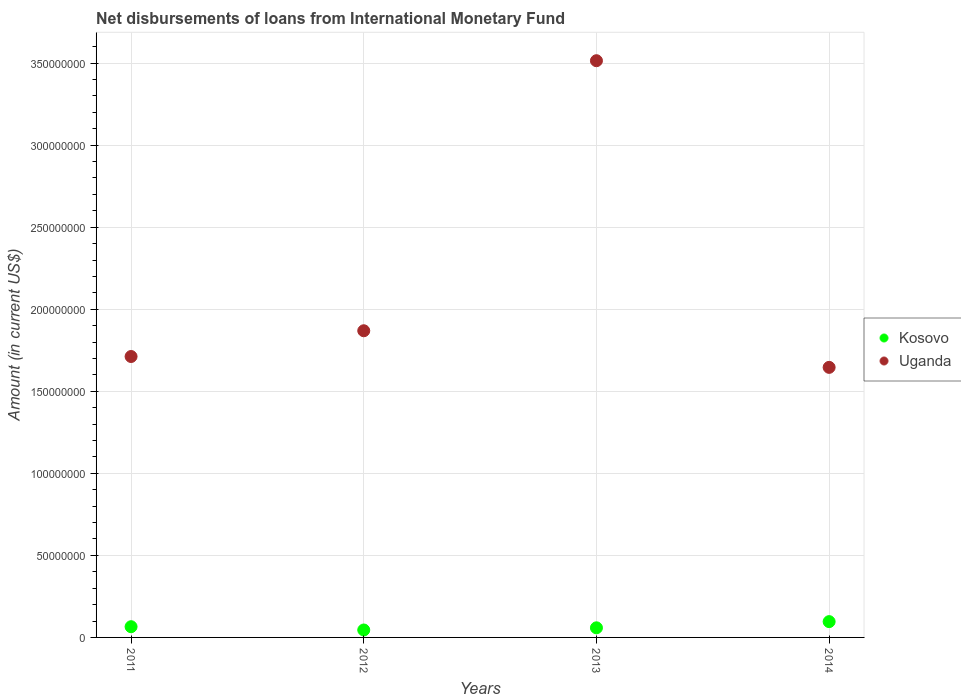Is the number of dotlines equal to the number of legend labels?
Provide a succinct answer. Yes. What is the amount of loans disbursed in Uganda in 2014?
Give a very brief answer. 1.65e+08. Across all years, what is the maximum amount of loans disbursed in Kosovo?
Offer a terse response. 9.63e+06. Across all years, what is the minimum amount of loans disbursed in Uganda?
Provide a succinct answer. 1.65e+08. In which year was the amount of loans disbursed in Uganda maximum?
Ensure brevity in your answer.  2013. In which year was the amount of loans disbursed in Uganda minimum?
Your response must be concise. 2014. What is the total amount of loans disbursed in Kosovo in the graph?
Provide a succinct answer. 2.66e+07. What is the difference between the amount of loans disbursed in Kosovo in 2011 and that in 2012?
Provide a succinct answer. 2.00e+06. What is the difference between the amount of loans disbursed in Kosovo in 2011 and the amount of loans disbursed in Uganda in 2014?
Your answer should be very brief. -1.58e+08. What is the average amount of loans disbursed in Uganda per year?
Ensure brevity in your answer.  2.19e+08. In the year 2011, what is the difference between the amount of loans disbursed in Uganda and amount of loans disbursed in Kosovo?
Ensure brevity in your answer.  1.65e+08. What is the ratio of the amount of loans disbursed in Kosovo in 2012 to that in 2013?
Provide a short and direct response. 0.77. What is the difference between the highest and the second highest amount of loans disbursed in Uganda?
Ensure brevity in your answer.  1.65e+08. What is the difference between the highest and the lowest amount of loans disbursed in Uganda?
Provide a short and direct response. 1.87e+08. Is the sum of the amount of loans disbursed in Uganda in 2012 and 2013 greater than the maximum amount of loans disbursed in Kosovo across all years?
Your response must be concise. Yes. Does the amount of loans disbursed in Kosovo monotonically increase over the years?
Provide a succinct answer. No. Is the amount of loans disbursed in Uganda strictly greater than the amount of loans disbursed in Kosovo over the years?
Your answer should be very brief. Yes. How many dotlines are there?
Keep it short and to the point. 2. Are the values on the major ticks of Y-axis written in scientific E-notation?
Your response must be concise. No. Does the graph contain any zero values?
Make the answer very short. No. Does the graph contain grids?
Make the answer very short. Yes. How many legend labels are there?
Offer a terse response. 2. What is the title of the graph?
Offer a terse response. Net disbursements of loans from International Monetary Fund. What is the label or title of the Y-axis?
Keep it short and to the point. Amount (in current US$). What is the Amount (in current US$) in Kosovo in 2011?
Your answer should be very brief. 6.53e+06. What is the Amount (in current US$) in Uganda in 2011?
Your answer should be compact. 1.71e+08. What is the Amount (in current US$) in Kosovo in 2012?
Your answer should be compact. 4.54e+06. What is the Amount (in current US$) in Uganda in 2012?
Your answer should be very brief. 1.87e+08. What is the Amount (in current US$) of Kosovo in 2013?
Your answer should be very brief. 5.86e+06. What is the Amount (in current US$) in Uganda in 2013?
Your answer should be compact. 3.51e+08. What is the Amount (in current US$) in Kosovo in 2014?
Offer a very short reply. 9.63e+06. What is the Amount (in current US$) in Uganda in 2014?
Ensure brevity in your answer.  1.65e+08. Across all years, what is the maximum Amount (in current US$) of Kosovo?
Provide a short and direct response. 9.63e+06. Across all years, what is the maximum Amount (in current US$) of Uganda?
Your response must be concise. 3.51e+08. Across all years, what is the minimum Amount (in current US$) of Kosovo?
Provide a succinct answer. 4.54e+06. Across all years, what is the minimum Amount (in current US$) in Uganda?
Ensure brevity in your answer.  1.65e+08. What is the total Amount (in current US$) of Kosovo in the graph?
Provide a succinct answer. 2.66e+07. What is the total Amount (in current US$) of Uganda in the graph?
Your response must be concise. 8.74e+08. What is the difference between the Amount (in current US$) in Kosovo in 2011 and that in 2012?
Make the answer very short. 2.00e+06. What is the difference between the Amount (in current US$) in Uganda in 2011 and that in 2012?
Keep it short and to the point. -1.57e+07. What is the difference between the Amount (in current US$) in Kosovo in 2011 and that in 2013?
Give a very brief answer. 6.76e+05. What is the difference between the Amount (in current US$) in Uganda in 2011 and that in 2013?
Your answer should be compact. -1.80e+08. What is the difference between the Amount (in current US$) of Kosovo in 2011 and that in 2014?
Offer a terse response. -3.10e+06. What is the difference between the Amount (in current US$) in Uganda in 2011 and that in 2014?
Keep it short and to the point. 6.62e+06. What is the difference between the Amount (in current US$) of Kosovo in 2012 and that in 2013?
Provide a succinct answer. -1.32e+06. What is the difference between the Amount (in current US$) in Uganda in 2012 and that in 2013?
Offer a very short reply. -1.65e+08. What is the difference between the Amount (in current US$) of Kosovo in 2012 and that in 2014?
Give a very brief answer. -5.10e+06. What is the difference between the Amount (in current US$) in Uganda in 2012 and that in 2014?
Keep it short and to the point. 2.23e+07. What is the difference between the Amount (in current US$) in Kosovo in 2013 and that in 2014?
Your response must be concise. -3.78e+06. What is the difference between the Amount (in current US$) of Uganda in 2013 and that in 2014?
Make the answer very short. 1.87e+08. What is the difference between the Amount (in current US$) in Kosovo in 2011 and the Amount (in current US$) in Uganda in 2012?
Ensure brevity in your answer.  -1.80e+08. What is the difference between the Amount (in current US$) of Kosovo in 2011 and the Amount (in current US$) of Uganda in 2013?
Your answer should be very brief. -3.45e+08. What is the difference between the Amount (in current US$) in Kosovo in 2011 and the Amount (in current US$) in Uganda in 2014?
Offer a very short reply. -1.58e+08. What is the difference between the Amount (in current US$) in Kosovo in 2012 and the Amount (in current US$) in Uganda in 2013?
Offer a terse response. -3.47e+08. What is the difference between the Amount (in current US$) of Kosovo in 2012 and the Amount (in current US$) of Uganda in 2014?
Your answer should be very brief. -1.60e+08. What is the difference between the Amount (in current US$) of Kosovo in 2013 and the Amount (in current US$) of Uganda in 2014?
Your answer should be compact. -1.59e+08. What is the average Amount (in current US$) in Kosovo per year?
Make the answer very short. 6.64e+06. What is the average Amount (in current US$) in Uganda per year?
Your answer should be very brief. 2.19e+08. In the year 2011, what is the difference between the Amount (in current US$) of Kosovo and Amount (in current US$) of Uganda?
Your response must be concise. -1.65e+08. In the year 2012, what is the difference between the Amount (in current US$) in Kosovo and Amount (in current US$) in Uganda?
Your answer should be very brief. -1.82e+08. In the year 2013, what is the difference between the Amount (in current US$) in Kosovo and Amount (in current US$) in Uganda?
Your answer should be very brief. -3.46e+08. In the year 2014, what is the difference between the Amount (in current US$) of Kosovo and Amount (in current US$) of Uganda?
Offer a terse response. -1.55e+08. What is the ratio of the Amount (in current US$) in Kosovo in 2011 to that in 2012?
Provide a succinct answer. 1.44. What is the ratio of the Amount (in current US$) of Uganda in 2011 to that in 2012?
Your response must be concise. 0.92. What is the ratio of the Amount (in current US$) in Kosovo in 2011 to that in 2013?
Offer a very short reply. 1.12. What is the ratio of the Amount (in current US$) of Uganda in 2011 to that in 2013?
Provide a short and direct response. 0.49. What is the ratio of the Amount (in current US$) of Kosovo in 2011 to that in 2014?
Your answer should be compact. 0.68. What is the ratio of the Amount (in current US$) of Uganda in 2011 to that in 2014?
Ensure brevity in your answer.  1.04. What is the ratio of the Amount (in current US$) of Kosovo in 2012 to that in 2013?
Provide a short and direct response. 0.77. What is the ratio of the Amount (in current US$) of Uganda in 2012 to that in 2013?
Offer a terse response. 0.53. What is the ratio of the Amount (in current US$) of Kosovo in 2012 to that in 2014?
Make the answer very short. 0.47. What is the ratio of the Amount (in current US$) of Uganda in 2012 to that in 2014?
Ensure brevity in your answer.  1.14. What is the ratio of the Amount (in current US$) of Kosovo in 2013 to that in 2014?
Your response must be concise. 0.61. What is the ratio of the Amount (in current US$) of Uganda in 2013 to that in 2014?
Provide a succinct answer. 2.14. What is the difference between the highest and the second highest Amount (in current US$) of Kosovo?
Your response must be concise. 3.10e+06. What is the difference between the highest and the second highest Amount (in current US$) in Uganda?
Your answer should be very brief. 1.65e+08. What is the difference between the highest and the lowest Amount (in current US$) in Kosovo?
Your answer should be very brief. 5.10e+06. What is the difference between the highest and the lowest Amount (in current US$) in Uganda?
Your response must be concise. 1.87e+08. 